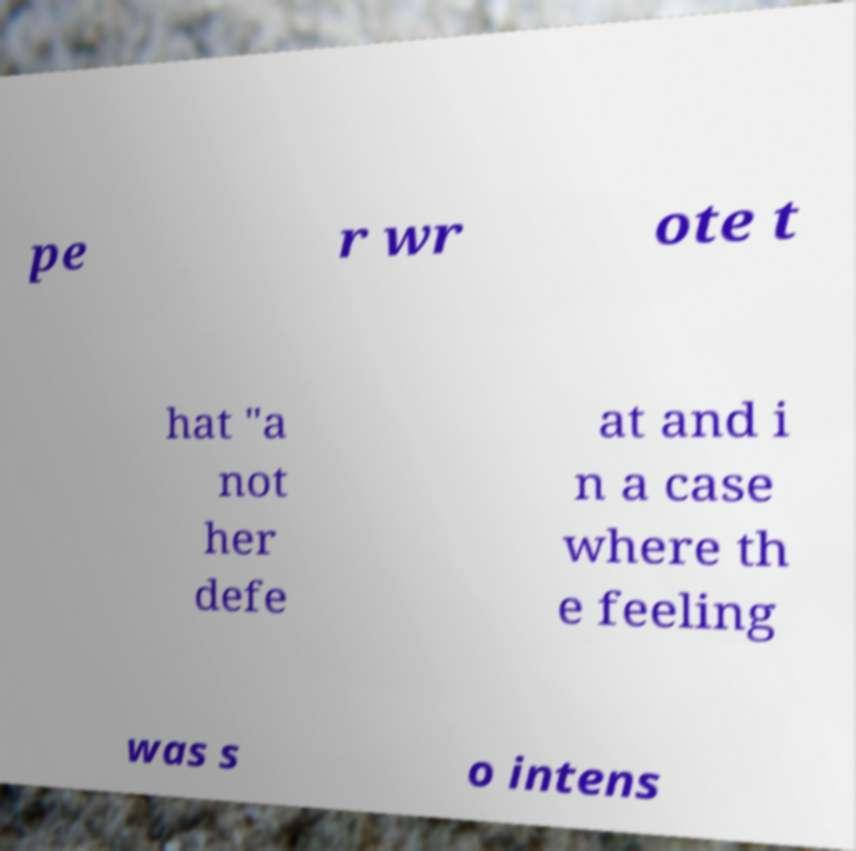For documentation purposes, I need the text within this image transcribed. Could you provide that? pe r wr ote t hat "a not her defe at and i n a case where th e feeling was s o intens 